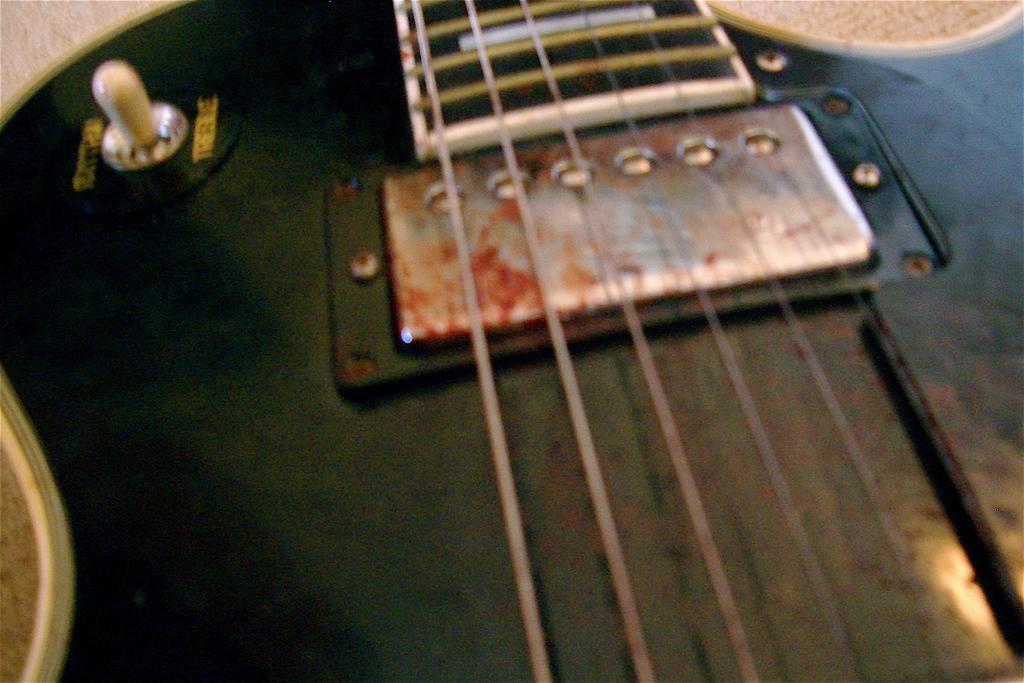Describe this image in one or two sentences. In this image we can see a close view of a guitar. We can see the strings. In the top left, we can see some text. 